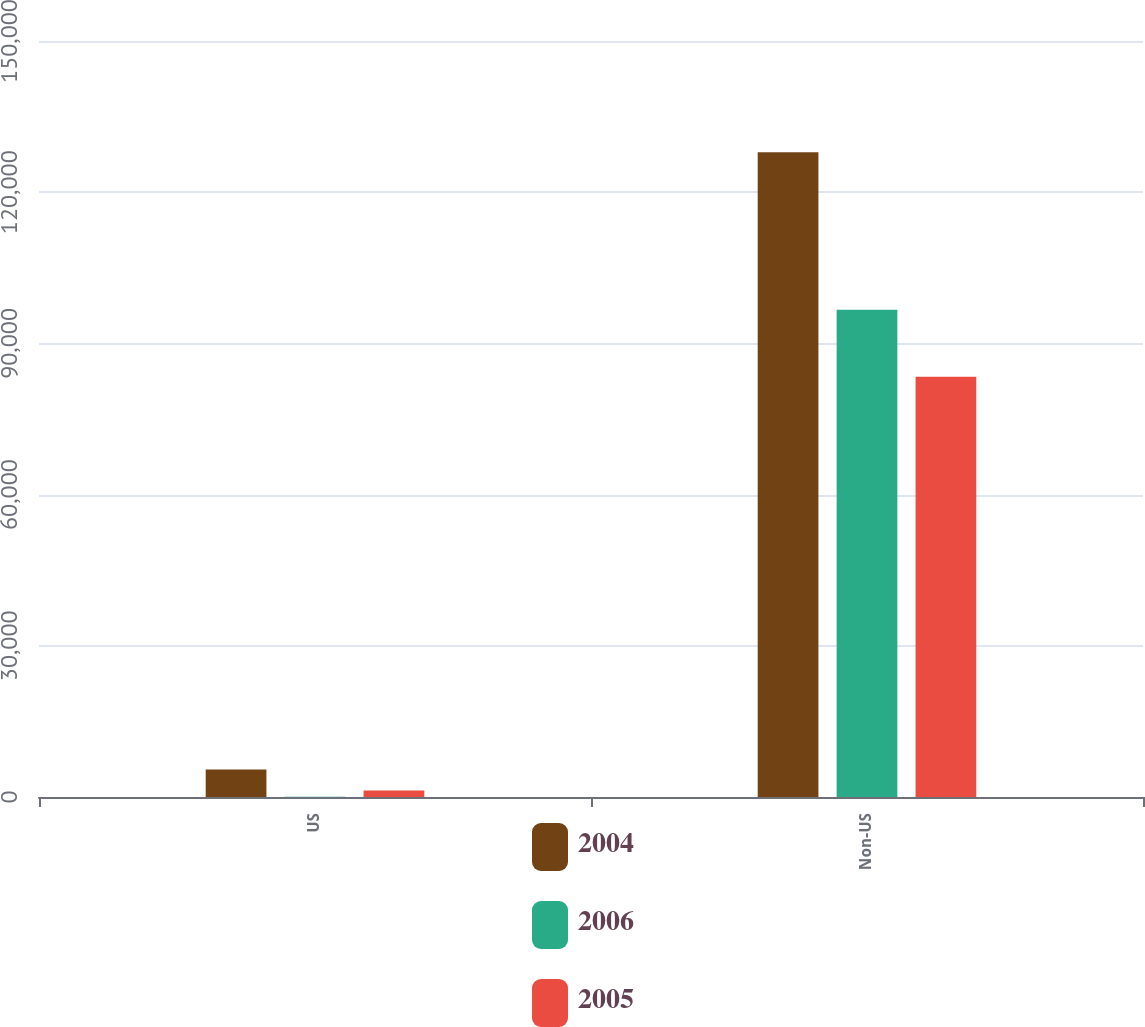Convert chart to OTSL. <chart><loc_0><loc_0><loc_500><loc_500><stacked_bar_chart><ecel><fcel>US<fcel>Non-US<nl><fcel>2004<fcel>5472<fcel>127922<nl><fcel>2006<fcel>54<fcel>96680<nl><fcel>2005<fcel>1290<fcel>83378<nl></chart> 